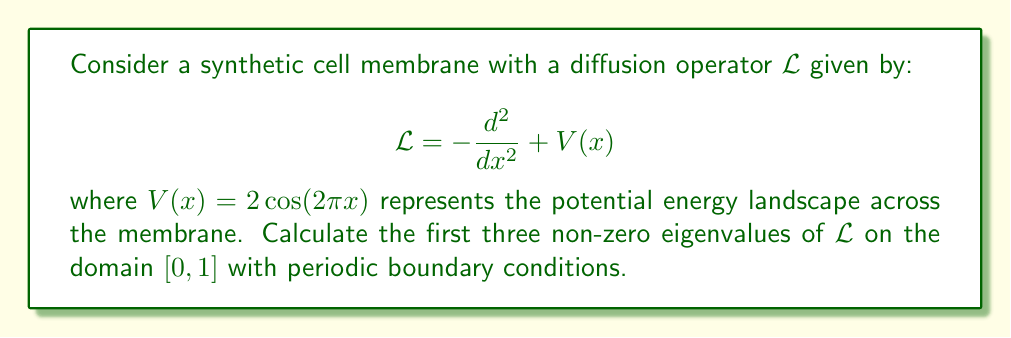Teach me how to tackle this problem. To solve this problem, we'll follow these steps:

1) The diffusion operator $\mathcal{L}$ is a Sturm-Liouville operator. For periodic boundary conditions on $[0,1]$, the eigenfunctions are of the form:

   $$\psi_n(x) = e^{2\pi i n x}$$

   where $n$ is an integer.

2) The eigenvalue equation is:

   $$\mathcal{L}\psi_n = \lambda_n \psi_n$$

3) Applying $\mathcal{L}$ to $\psi_n$:

   $$\mathcal{L}\psi_n = -\frac{d^2}{dx^2}e^{2\pi i n x} + 2\cos(2\pi x)e^{2\pi i n x}$$

4) Simplify:

   $$\mathcal{L}\psi_n = (2\pi n)^2 e^{2\pi i n x} + 2\cos(2\pi x)e^{2\pi i n x}$$

5) Using Euler's formula, $\cos(2\pi x) = \frac{1}{2}(e^{2\pi i x} + e^{-2\pi i x})$:

   $$\mathcal{L}\psi_n = (2\pi n)^2 e^{2\pi i n x} + (e^{2\pi i x} + e^{-2\pi i x})e^{2\pi i n x}$$

6) Simplify:

   $$\mathcal{L}\psi_n = [(2\pi n)^2 + e^{2\pi i x} + e^{-2\pi i x}]e^{2\pi i n x}$$

7) The eigenvalues are:

   $$\lambda_n = (2\pi n)^2 + \delta_{n,1} + \delta_{n,-1}$$

   where $\delta_{n,m}$ is the Kronecker delta.

8) The first three non-zero eigenvalues are:

   For $n = \pm 1$: $\lambda_{\pm 1} = (2\pi)^2 + 1 = 4\pi^2 + 1$
   For $n = \pm 2$: $\lambda_{\pm 2} = (4\pi)^2 = 16\pi^2$
   For $n = \pm 3$: $\lambda_{\pm 3} = (6\pi)^2 = 36\pi^2$
Answer: $4\pi^2 + 1$, $16\pi^2$, $36\pi^2$ 